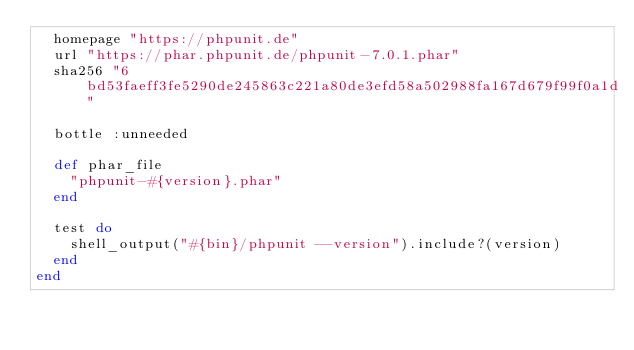<code> <loc_0><loc_0><loc_500><loc_500><_Ruby_>  homepage "https://phpunit.de"
  url "https://phar.phpunit.de/phpunit-7.0.1.phar"
  sha256 "6bd53faeff3fe5290de245863c221a80de3efd58a502988fa167d679f99f0a1d"

  bottle :unneeded

  def phar_file
    "phpunit-#{version}.phar"
  end

  test do
    shell_output("#{bin}/phpunit --version").include?(version)
  end
end
</code> 